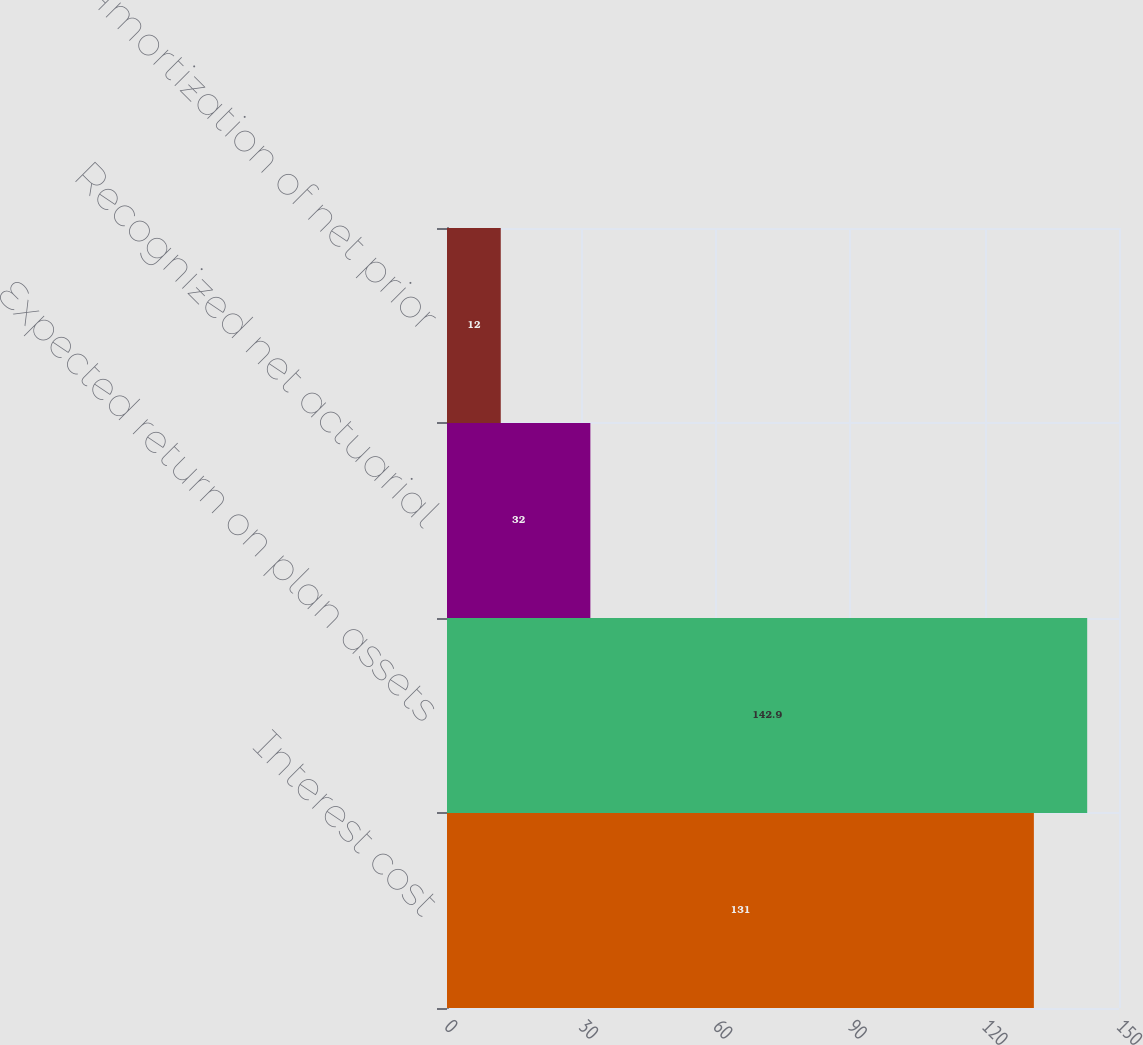Convert chart to OTSL. <chart><loc_0><loc_0><loc_500><loc_500><bar_chart><fcel>Interest cost<fcel>Expected return on plan assets<fcel>Recognized net actuarial<fcel>Amortization of net prior<nl><fcel>131<fcel>142.9<fcel>32<fcel>12<nl></chart> 